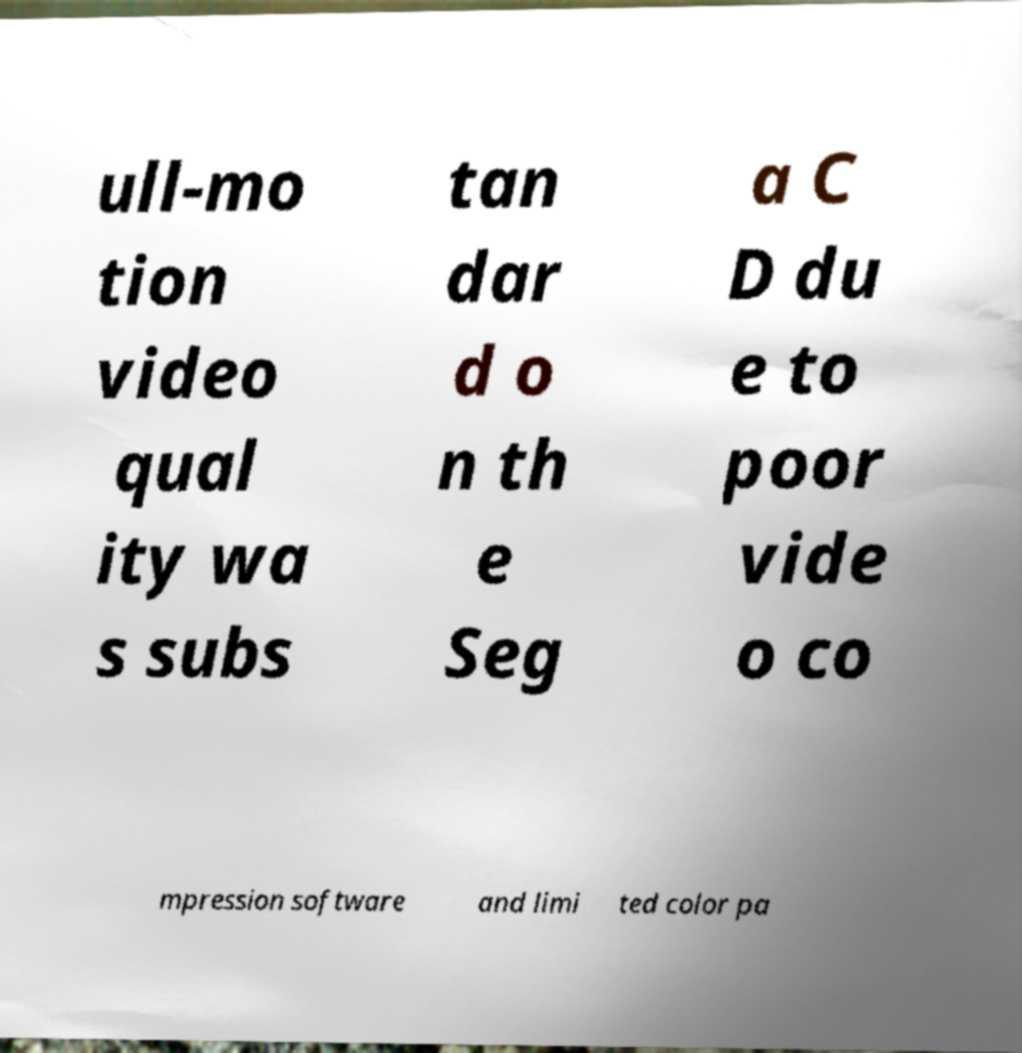Could you extract and type out the text from this image? ull-mo tion video qual ity wa s subs tan dar d o n th e Seg a C D du e to poor vide o co mpression software and limi ted color pa 